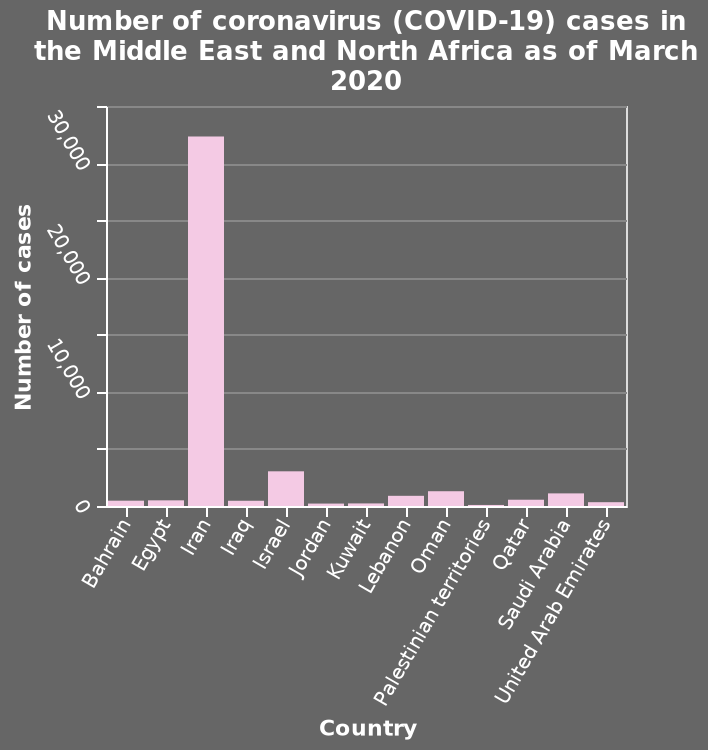<image>
please enumerates aspects of the construction of the chart Number of coronavirus (COVID-19) cases in the Middle East and North Africa as of March 2020 is a bar graph. The y-axis plots Number of cases on linear scale from 0 to 35,000 while the x-axis measures Country using categorical scale from Bahrain to United Arab Emirates. please summary the statistics and relations of the chart The bar graph shows the Number of coronavirus (COVID-19) cases inthe Middle East and North Africa to be showing a clear highest country. Iran is clearly the most severely effected by the virus as is it has many more cases than the countries listed. Iran has over 30,000 cases of Covid in this time period with the next highest being Israel with the cases being not even 50,000. Therefore this graph really highlights the mass number of cases experienced in the middle astern country of Iran. Is the number of coronavirus (COVID-19) cases in the Middle East and North Africa as of March 2020 represented as a pie chart? No.Number of coronavirus (COVID-19) cases in the Middle East and North Africa as of March 2020 is a bar graph. The y-axis plots Number of cases on linear scale from 0 to 35,000 while the x-axis measures Country using categorical scale from Bahrain to United Arab Emirates. 